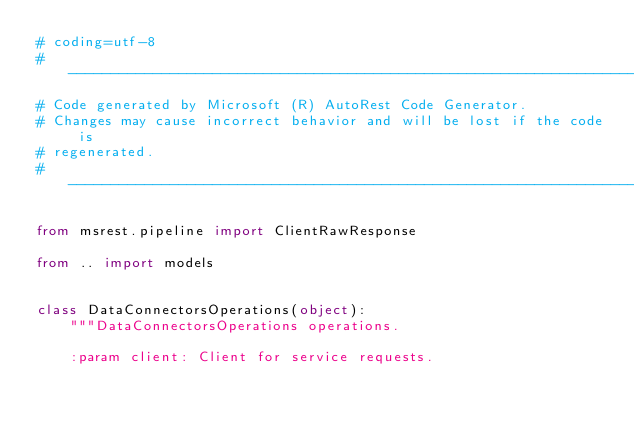<code> <loc_0><loc_0><loc_500><loc_500><_Python_># coding=utf-8
# --------------------------------------------------------------------------
# Code generated by Microsoft (R) AutoRest Code Generator.
# Changes may cause incorrect behavior and will be lost if the code is
# regenerated.
# --------------------------------------------------------------------------

from msrest.pipeline import ClientRawResponse

from .. import models


class DataConnectorsOperations(object):
    """DataConnectorsOperations operations.

    :param client: Client for service requests.</code> 